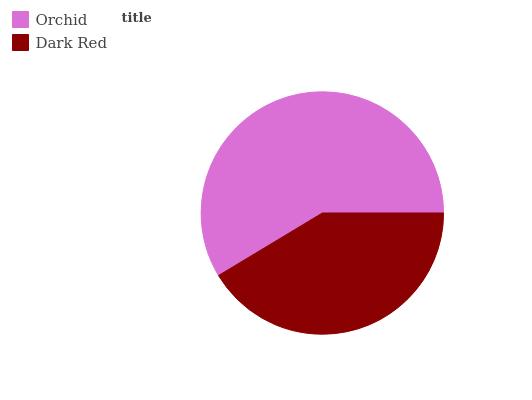Is Dark Red the minimum?
Answer yes or no. Yes. Is Orchid the maximum?
Answer yes or no. Yes. Is Dark Red the maximum?
Answer yes or no. No. Is Orchid greater than Dark Red?
Answer yes or no. Yes. Is Dark Red less than Orchid?
Answer yes or no. Yes. Is Dark Red greater than Orchid?
Answer yes or no. No. Is Orchid less than Dark Red?
Answer yes or no. No. Is Orchid the high median?
Answer yes or no. Yes. Is Dark Red the low median?
Answer yes or no. Yes. Is Dark Red the high median?
Answer yes or no. No. Is Orchid the low median?
Answer yes or no. No. 